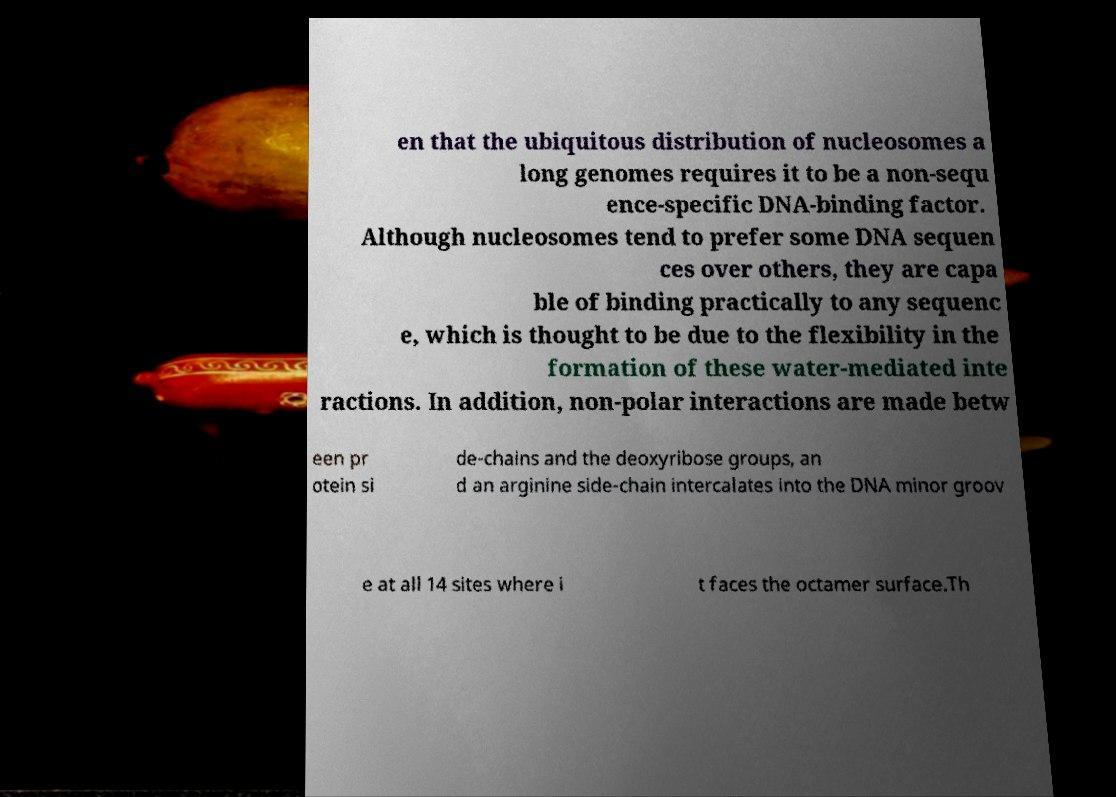Please read and relay the text visible in this image. What does it say? en that the ubiquitous distribution of nucleosomes a long genomes requires it to be a non-sequ ence-specific DNA-binding factor. Although nucleosomes tend to prefer some DNA sequen ces over others, they are capa ble of binding practically to any sequenc e, which is thought to be due to the flexibility in the formation of these water-mediated inte ractions. In addition, non-polar interactions are made betw een pr otein si de-chains and the deoxyribose groups, an d an arginine side-chain intercalates into the DNA minor groov e at all 14 sites where i t faces the octamer surface.Th 